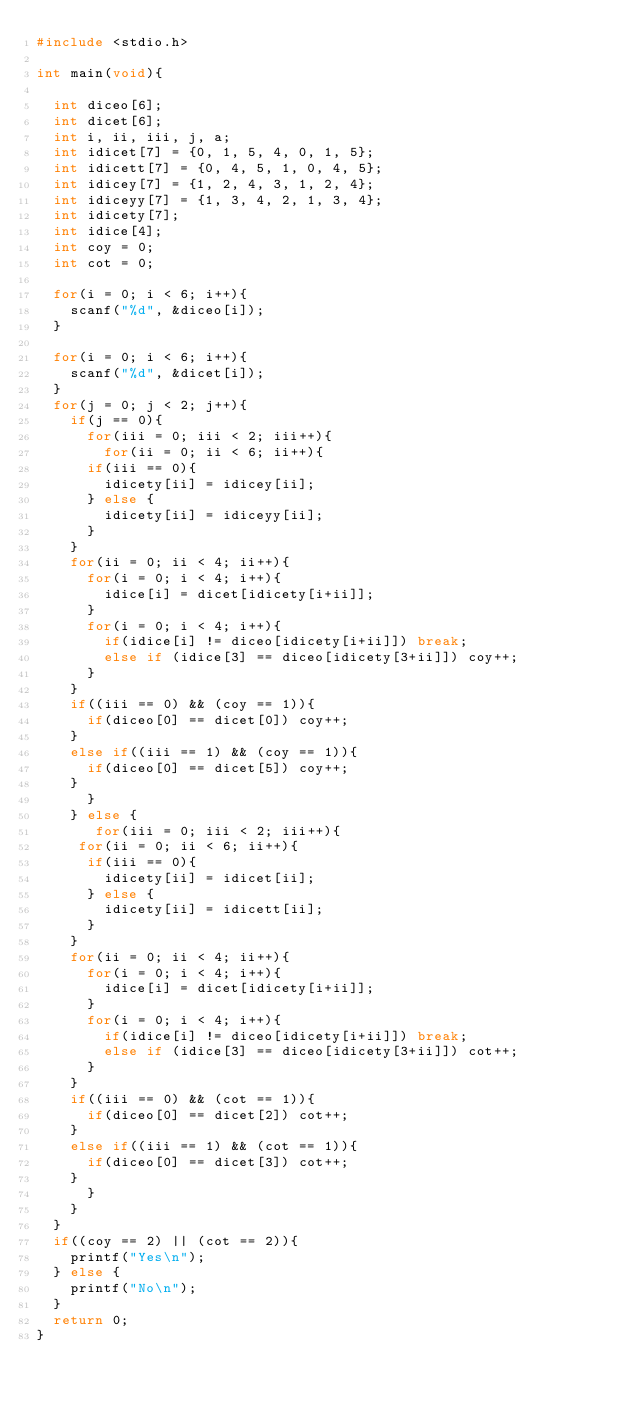Convert code to text. <code><loc_0><loc_0><loc_500><loc_500><_C_>#include <stdio.h>

int main(void){

  int diceo[6];
  int dicet[6];
  int i, ii, iii, j, a;
  int idicet[7] = {0, 1, 5, 4, 0, 1, 5};
  int idicett[7] = {0, 4, 5, 1, 0, 4, 5};
  int idicey[7] = {1, 2, 4, 3, 1, 2, 4};
  int idiceyy[7] = {1, 3, 4, 2, 1, 3, 4};
  int idicety[7];
  int idice[4];
  int coy = 0;
  int cot = 0;
  
  for(i = 0; i < 6; i++){
    scanf("%d", &diceo[i]);
  }
  
  for(i = 0; i < 6; i++){
    scanf("%d", &dicet[i]);
  }
  for(j = 0; j < 2; j++){  
    if(j == 0){
      for(iii = 0; iii < 2; iii++){
        for(ii = 0; ii < 6; ii++){ 
	  if(iii == 0){
	    idicety[ii] = idicey[ii];
	  } else {
	    idicety[ii] = idiceyy[ii];
	  }
	}
	for(ii = 0; ii < 4; ii++){
	  for(i = 0; i < 4; i++){ 
	    idice[i] = dicet[idicety[i+ii]];
	  }
	  for(i = 0; i < 4; i++){
	    if(idice[i] != diceo[idicety[i+ii]]) break;
	    else if (idice[3] == diceo[idicety[3+ii]]) coy++;
	  }
	}
	if((iii == 0) && (coy == 1)){
	  if(diceo[0] == dicet[0]) coy++;
	}
	else if((iii == 1) && (coy == 1)){
	  if(diceo[0] == dicet[5]) coy++;
	}
      }
    } else {
       for(iii = 0; iii < 2; iii++){
	 for(ii = 0; ii < 6; ii++){ 
	  if(iii == 0){
	    idicety[ii] = idicet[ii];
	  } else {
	    idicety[ii] = idicett[ii];
	  }
	}
	for(ii = 0; ii < 4; ii++){ 
	  for(i = 0; i < 4; i++){ 
	    idice[i] = dicet[idicety[i+ii]];
	  }
	  for(i = 0; i < 4; i++){
	    if(idice[i] != diceo[idicety[i+ii]]) break;
	    else if (idice[3] == diceo[idicety[3+ii]]) cot++;
	  }
	}
	if((iii == 0) && (cot == 1)){
	  if(diceo[0] == dicet[2]) cot++;
	}
	else if((iii == 1) && (cot == 1)){
	  if(diceo[0] == dicet[3]) cot++;
	}
      }
    }
  }
  if((coy == 2) || (cot == 2)){
    printf("Yes\n");
  } else {
    printf("No\n");
  }
  return 0;
}</code> 